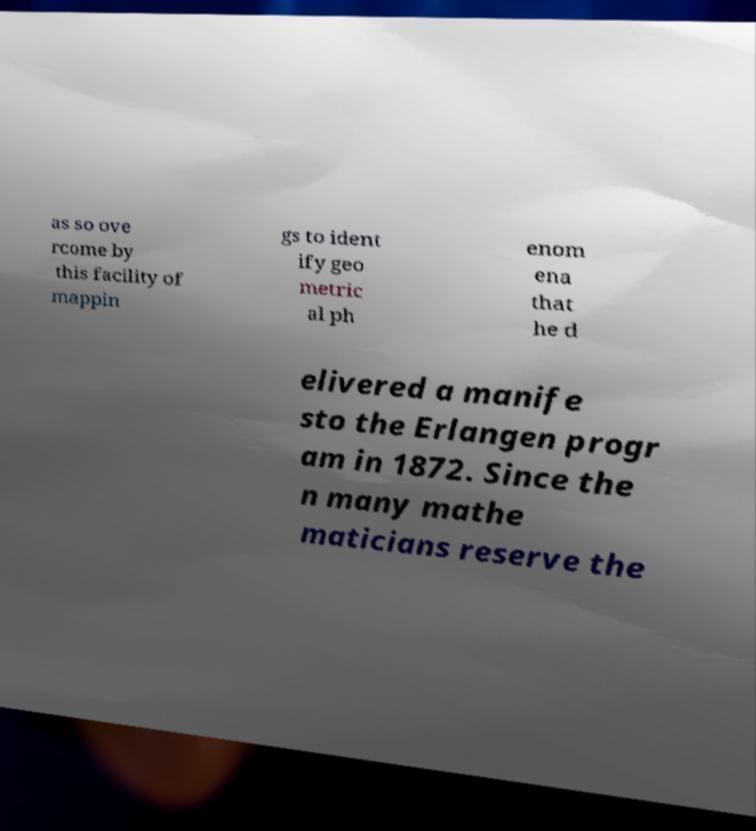Please read and relay the text visible in this image. What does it say? as so ove rcome by this facility of mappin gs to ident ify geo metric al ph enom ena that he d elivered a manife sto the Erlangen progr am in 1872. Since the n many mathe maticians reserve the 